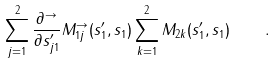Convert formula to latex. <formula><loc_0><loc_0><loc_500><loc_500>\sum _ { j = 1 } ^ { 2 } \frac { \partial ^ { \to } } { \partial s _ { j 1 } ^ { \prime } } M _ { 1 j } ^ { \to } ( s _ { 1 } ^ { \prime } , s _ { 1 } ) \sum _ { k = 1 } ^ { 2 } M _ { 2 k } ( s _ { 1 } ^ { \prime } , s _ { 1 } ) \quad .</formula> 